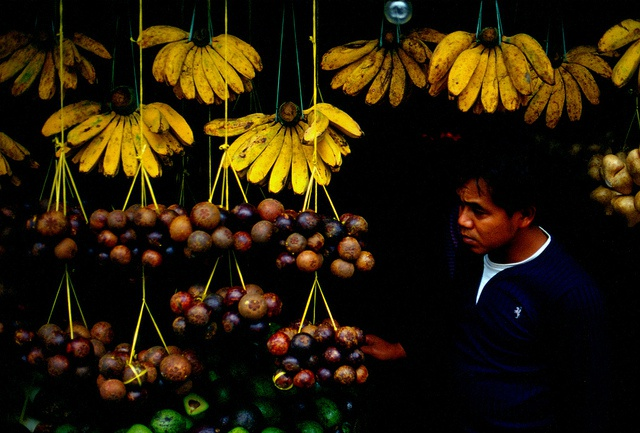Describe the objects in this image and their specific colors. I can see people in black, maroon, and brown tones, banana in black, orange, gold, and olive tones, banana in black, orange, and olive tones, banana in black, orange, olive, and maroon tones, and banana in black, orange, and olive tones in this image. 